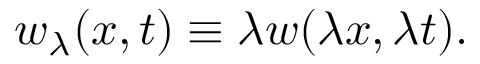Convert formula to latex. <formula><loc_0><loc_0><loc_500><loc_500>w _ { \lambda } ( x , t ) \equiv \lambda w ( \lambda x , \lambda t ) .</formula> 